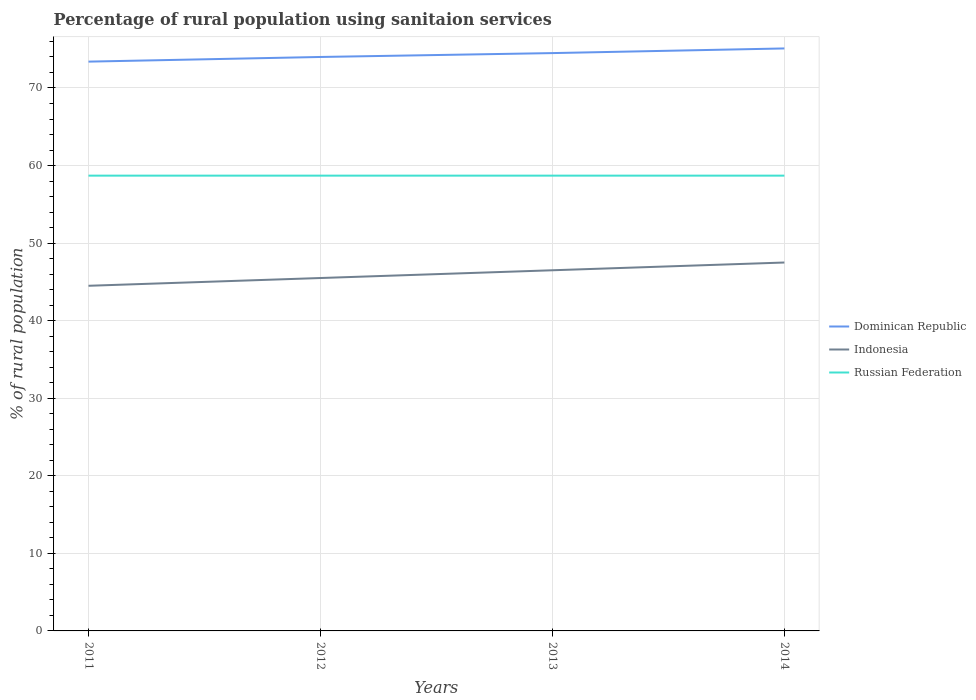How many different coloured lines are there?
Your answer should be very brief. 3. Does the line corresponding to Indonesia intersect with the line corresponding to Dominican Republic?
Ensure brevity in your answer.  No. Is the number of lines equal to the number of legend labels?
Make the answer very short. Yes. Across all years, what is the maximum percentage of rural population using sanitaion services in Indonesia?
Your response must be concise. 44.5. What is the difference between the highest and the second highest percentage of rural population using sanitaion services in Dominican Republic?
Keep it short and to the point. 1.7. What is the difference between the highest and the lowest percentage of rural population using sanitaion services in Dominican Republic?
Give a very brief answer. 2. Is the percentage of rural population using sanitaion services in Dominican Republic strictly greater than the percentage of rural population using sanitaion services in Indonesia over the years?
Give a very brief answer. No. How many lines are there?
Ensure brevity in your answer.  3. How many years are there in the graph?
Make the answer very short. 4. Are the values on the major ticks of Y-axis written in scientific E-notation?
Provide a succinct answer. No. How many legend labels are there?
Make the answer very short. 3. What is the title of the graph?
Offer a very short reply. Percentage of rural population using sanitaion services. Does "Iraq" appear as one of the legend labels in the graph?
Give a very brief answer. No. What is the label or title of the X-axis?
Offer a terse response. Years. What is the label or title of the Y-axis?
Offer a very short reply. % of rural population. What is the % of rural population in Dominican Republic in 2011?
Provide a short and direct response. 73.4. What is the % of rural population of Indonesia in 2011?
Offer a very short reply. 44.5. What is the % of rural population in Russian Federation in 2011?
Your response must be concise. 58.7. What is the % of rural population in Dominican Republic in 2012?
Your answer should be very brief. 74. What is the % of rural population of Indonesia in 2012?
Your answer should be very brief. 45.5. What is the % of rural population of Russian Federation in 2012?
Offer a terse response. 58.7. What is the % of rural population in Dominican Republic in 2013?
Your answer should be compact. 74.5. What is the % of rural population in Indonesia in 2013?
Ensure brevity in your answer.  46.5. What is the % of rural population of Russian Federation in 2013?
Ensure brevity in your answer.  58.7. What is the % of rural population of Dominican Republic in 2014?
Provide a short and direct response. 75.1. What is the % of rural population in Indonesia in 2014?
Ensure brevity in your answer.  47.5. What is the % of rural population of Russian Federation in 2014?
Your answer should be compact. 58.7. Across all years, what is the maximum % of rural population of Dominican Republic?
Provide a short and direct response. 75.1. Across all years, what is the maximum % of rural population of Indonesia?
Offer a very short reply. 47.5. Across all years, what is the maximum % of rural population of Russian Federation?
Provide a succinct answer. 58.7. Across all years, what is the minimum % of rural population of Dominican Republic?
Offer a very short reply. 73.4. Across all years, what is the minimum % of rural population in Indonesia?
Your answer should be very brief. 44.5. Across all years, what is the minimum % of rural population in Russian Federation?
Make the answer very short. 58.7. What is the total % of rural population in Dominican Republic in the graph?
Make the answer very short. 297. What is the total % of rural population in Indonesia in the graph?
Your response must be concise. 184. What is the total % of rural population in Russian Federation in the graph?
Ensure brevity in your answer.  234.8. What is the difference between the % of rural population of Dominican Republic in 2011 and that in 2012?
Your answer should be very brief. -0.6. What is the difference between the % of rural population of Russian Federation in 2011 and that in 2013?
Make the answer very short. 0. What is the difference between the % of rural population in Indonesia in 2011 and that in 2014?
Ensure brevity in your answer.  -3. What is the difference between the % of rural population in Russian Federation in 2011 and that in 2014?
Provide a short and direct response. 0. What is the difference between the % of rural population in Dominican Republic in 2012 and that in 2013?
Make the answer very short. -0.5. What is the difference between the % of rural population in Indonesia in 2012 and that in 2014?
Provide a succinct answer. -2. What is the difference between the % of rural population in Russian Federation in 2012 and that in 2014?
Your response must be concise. 0. What is the difference between the % of rural population of Indonesia in 2013 and that in 2014?
Make the answer very short. -1. What is the difference between the % of rural population of Dominican Republic in 2011 and the % of rural population of Indonesia in 2012?
Ensure brevity in your answer.  27.9. What is the difference between the % of rural population of Dominican Republic in 2011 and the % of rural population of Russian Federation in 2012?
Offer a very short reply. 14.7. What is the difference between the % of rural population in Dominican Republic in 2011 and the % of rural population in Indonesia in 2013?
Keep it short and to the point. 26.9. What is the difference between the % of rural population of Indonesia in 2011 and the % of rural population of Russian Federation in 2013?
Provide a short and direct response. -14.2. What is the difference between the % of rural population in Dominican Republic in 2011 and the % of rural population in Indonesia in 2014?
Your answer should be very brief. 25.9. What is the difference between the % of rural population of Indonesia in 2011 and the % of rural population of Russian Federation in 2014?
Your answer should be very brief. -14.2. What is the difference between the % of rural population in Dominican Republic in 2012 and the % of rural population in Indonesia in 2013?
Your response must be concise. 27.5. What is the difference between the % of rural population in Dominican Republic in 2012 and the % of rural population in Russian Federation in 2014?
Your response must be concise. 15.3. What is the difference between the % of rural population in Dominican Republic in 2013 and the % of rural population in Indonesia in 2014?
Make the answer very short. 27. What is the difference between the % of rural population of Dominican Republic in 2013 and the % of rural population of Russian Federation in 2014?
Keep it short and to the point. 15.8. What is the difference between the % of rural population of Indonesia in 2013 and the % of rural population of Russian Federation in 2014?
Offer a very short reply. -12.2. What is the average % of rural population of Dominican Republic per year?
Give a very brief answer. 74.25. What is the average % of rural population in Indonesia per year?
Provide a succinct answer. 46. What is the average % of rural population in Russian Federation per year?
Your answer should be compact. 58.7. In the year 2011, what is the difference between the % of rural population of Dominican Republic and % of rural population of Indonesia?
Make the answer very short. 28.9. In the year 2011, what is the difference between the % of rural population in Indonesia and % of rural population in Russian Federation?
Offer a terse response. -14.2. In the year 2012, what is the difference between the % of rural population in Dominican Republic and % of rural population in Indonesia?
Provide a short and direct response. 28.5. In the year 2012, what is the difference between the % of rural population in Dominican Republic and % of rural population in Russian Federation?
Your answer should be very brief. 15.3. In the year 2013, what is the difference between the % of rural population of Indonesia and % of rural population of Russian Federation?
Your answer should be very brief. -12.2. In the year 2014, what is the difference between the % of rural population in Dominican Republic and % of rural population in Indonesia?
Your answer should be compact. 27.6. What is the ratio of the % of rural population of Dominican Republic in 2011 to that in 2012?
Your response must be concise. 0.99. What is the ratio of the % of rural population in Indonesia in 2011 to that in 2012?
Offer a very short reply. 0.98. What is the ratio of the % of rural population of Russian Federation in 2011 to that in 2012?
Your answer should be compact. 1. What is the ratio of the % of rural population of Dominican Republic in 2011 to that in 2013?
Provide a succinct answer. 0.99. What is the ratio of the % of rural population of Dominican Republic in 2011 to that in 2014?
Your answer should be very brief. 0.98. What is the ratio of the % of rural population of Indonesia in 2011 to that in 2014?
Provide a short and direct response. 0.94. What is the ratio of the % of rural population of Russian Federation in 2011 to that in 2014?
Make the answer very short. 1. What is the ratio of the % of rural population in Indonesia in 2012 to that in 2013?
Your answer should be compact. 0.98. What is the ratio of the % of rural population of Russian Federation in 2012 to that in 2013?
Provide a succinct answer. 1. What is the ratio of the % of rural population of Dominican Republic in 2012 to that in 2014?
Your answer should be very brief. 0.99. What is the ratio of the % of rural population in Indonesia in 2012 to that in 2014?
Give a very brief answer. 0.96. What is the ratio of the % of rural population of Indonesia in 2013 to that in 2014?
Offer a very short reply. 0.98. What is the ratio of the % of rural population in Russian Federation in 2013 to that in 2014?
Provide a short and direct response. 1. What is the difference between the highest and the second highest % of rural population of Dominican Republic?
Your answer should be very brief. 0.6. What is the difference between the highest and the second highest % of rural population in Russian Federation?
Keep it short and to the point. 0. What is the difference between the highest and the lowest % of rural population of Dominican Republic?
Keep it short and to the point. 1.7. What is the difference between the highest and the lowest % of rural population of Russian Federation?
Offer a terse response. 0. 